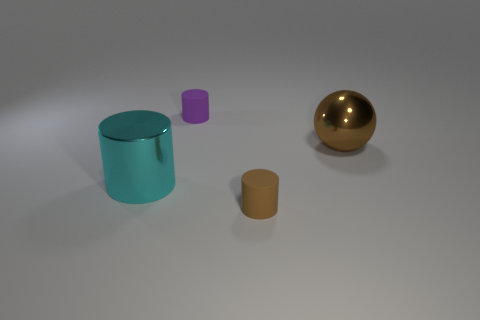Add 4 red shiny cylinders. How many objects exist? 8 Subtract all spheres. How many objects are left? 3 Subtract 0 purple cubes. How many objects are left? 4 Subtract all small gray metallic cylinders. Subtract all tiny brown objects. How many objects are left? 3 Add 2 brown rubber cylinders. How many brown rubber cylinders are left? 3 Add 3 small purple balls. How many small purple balls exist? 3 